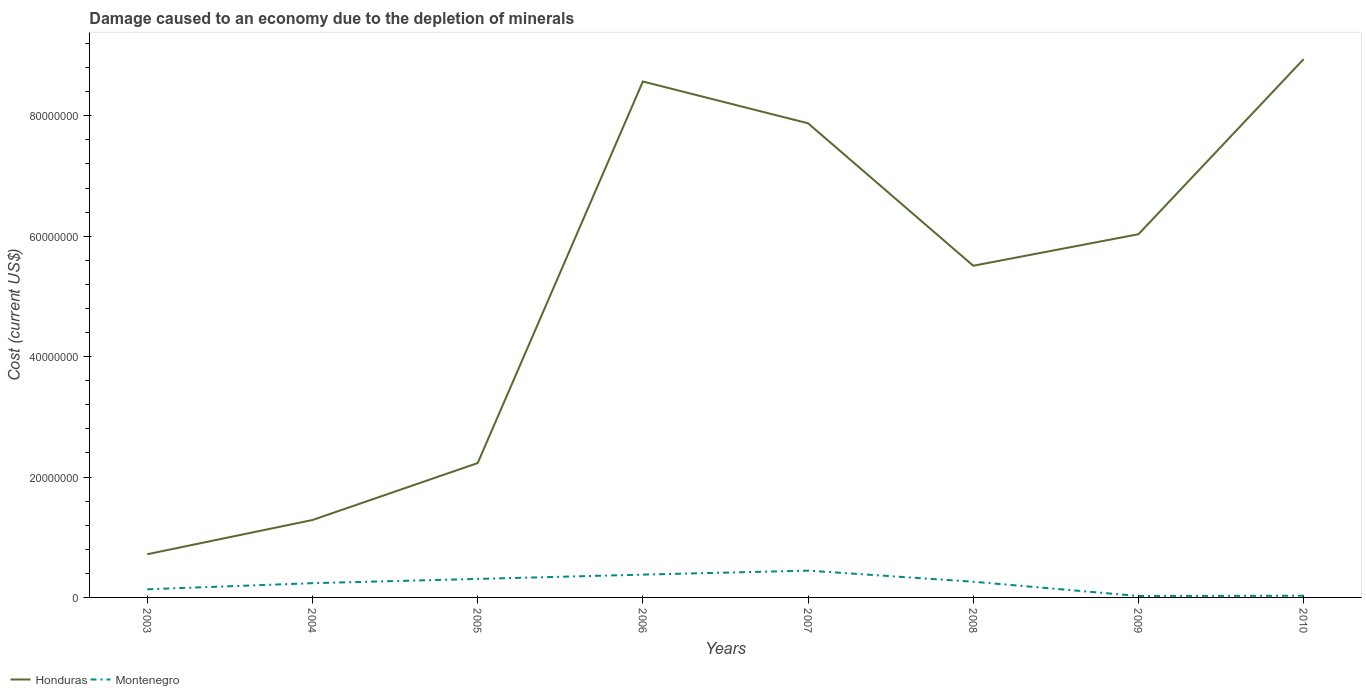Is the number of lines equal to the number of legend labels?
Offer a terse response. Yes. Across all years, what is the maximum cost of damage caused due to the depletion of minerals in Honduras?
Provide a short and direct response. 7.18e+06. What is the total cost of damage caused due to the depletion of minerals in Montenegro in the graph?
Your response must be concise. 3.51e+06. What is the difference between the highest and the second highest cost of damage caused due to the depletion of minerals in Montenegro?
Offer a very short reply. 4.21e+06. What is the difference between the highest and the lowest cost of damage caused due to the depletion of minerals in Montenegro?
Give a very brief answer. 5. How many lines are there?
Your answer should be very brief. 2. How many years are there in the graph?
Make the answer very short. 8. Does the graph contain any zero values?
Make the answer very short. No. Where does the legend appear in the graph?
Provide a succinct answer. Bottom left. How many legend labels are there?
Ensure brevity in your answer.  2. What is the title of the graph?
Give a very brief answer. Damage caused to an economy due to the depletion of minerals. What is the label or title of the Y-axis?
Provide a succinct answer. Cost (current US$). What is the Cost (current US$) of Honduras in 2003?
Offer a very short reply. 7.18e+06. What is the Cost (current US$) of Montenegro in 2003?
Keep it short and to the point. 1.35e+06. What is the Cost (current US$) of Honduras in 2004?
Your response must be concise. 1.29e+07. What is the Cost (current US$) in Montenegro in 2004?
Keep it short and to the point. 2.37e+06. What is the Cost (current US$) in Honduras in 2005?
Provide a succinct answer. 2.23e+07. What is the Cost (current US$) in Montenegro in 2005?
Your answer should be very brief. 3.07e+06. What is the Cost (current US$) in Honduras in 2006?
Provide a succinct answer. 8.57e+07. What is the Cost (current US$) of Montenegro in 2006?
Offer a very short reply. 3.79e+06. What is the Cost (current US$) in Honduras in 2007?
Your answer should be compact. 7.87e+07. What is the Cost (current US$) of Montenegro in 2007?
Your response must be concise. 4.45e+06. What is the Cost (current US$) of Honduras in 2008?
Make the answer very short. 5.51e+07. What is the Cost (current US$) in Montenegro in 2008?
Keep it short and to the point. 2.61e+06. What is the Cost (current US$) in Honduras in 2009?
Provide a short and direct response. 6.03e+07. What is the Cost (current US$) in Montenegro in 2009?
Provide a succinct answer. 2.40e+05. What is the Cost (current US$) of Honduras in 2010?
Your answer should be very brief. 8.94e+07. What is the Cost (current US$) of Montenegro in 2010?
Keep it short and to the point. 2.78e+05. Across all years, what is the maximum Cost (current US$) of Honduras?
Offer a terse response. 8.94e+07. Across all years, what is the maximum Cost (current US$) of Montenegro?
Your answer should be very brief. 4.45e+06. Across all years, what is the minimum Cost (current US$) of Honduras?
Provide a succinct answer. 7.18e+06. Across all years, what is the minimum Cost (current US$) of Montenegro?
Your answer should be compact. 2.40e+05. What is the total Cost (current US$) of Honduras in the graph?
Provide a succinct answer. 4.12e+08. What is the total Cost (current US$) in Montenegro in the graph?
Your answer should be very brief. 1.82e+07. What is the difference between the Cost (current US$) of Honduras in 2003 and that in 2004?
Make the answer very short. -5.68e+06. What is the difference between the Cost (current US$) in Montenegro in 2003 and that in 2004?
Offer a very short reply. -1.02e+06. What is the difference between the Cost (current US$) in Honduras in 2003 and that in 2005?
Offer a very short reply. -1.51e+07. What is the difference between the Cost (current US$) of Montenegro in 2003 and that in 2005?
Offer a very short reply. -1.72e+06. What is the difference between the Cost (current US$) in Honduras in 2003 and that in 2006?
Ensure brevity in your answer.  -7.85e+07. What is the difference between the Cost (current US$) of Montenegro in 2003 and that in 2006?
Offer a very short reply. -2.44e+06. What is the difference between the Cost (current US$) in Honduras in 2003 and that in 2007?
Your answer should be very brief. -7.16e+07. What is the difference between the Cost (current US$) of Montenegro in 2003 and that in 2007?
Your response must be concise. -3.10e+06. What is the difference between the Cost (current US$) in Honduras in 2003 and that in 2008?
Keep it short and to the point. -4.79e+07. What is the difference between the Cost (current US$) of Montenegro in 2003 and that in 2008?
Your answer should be compact. -1.26e+06. What is the difference between the Cost (current US$) in Honduras in 2003 and that in 2009?
Offer a terse response. -5.32e+07. What is the difference between the Cost (current US$) of Montenegro in 2003 and that in 2009?
Give a very brief answer. 1.11e+06. What is the difference between the Cost (current US$) in Honduras in 2003 and that in 2010?
Make the answer very short. -8.22e+07. What is the difference between the Cost (current US$) in Montenegro in 2003 and that in 2010?
Make the answer very short. 1.07e+06. What is the difference between the Cost (current US$) in Honduras in 2004 and that in 2005?
Your answer should be compact. -9.46e+06. What is the difference between the Cost (current US$) of Montenegro in 2004 and that in 2005?
Give a very brief answer. -7.07e+05. What is the difference between the Cost (current US$) of Honduras in 2004 and that in 2006?
Provide a succinct answer. -7.28e+07. What is the difference between the Cost (current US$) in Montenegro in 2004 and that in 2006?
Offer a very short reply. -1.42e+06. What is the difference between the Cost (current US$) of Honduras in 2004 and that in 2007?
Provide a short and direct response. -6.59e+07. What is the difference between the Cost (current US$) of Montenegro in 2004 and that in 2007?
Make the answer very short. -2.08e+06. What is the difference between the Cost (current US$) of Honduras in 2004 and that in 2008?
Your answer should be very brief. -4.22e+07. What is the difference between the Cost (current US$) in Montenegro in 2004 and that in 2008?
Ensure brevity in your answer.  -2.40e+05. What is the difference between the Cost (current US$) of Honduras in 2004 and that in 2009?
Offer a very short reply. -4.75e+07. What is the difference between the Cost (current US$) in Montenegro in 2004 and that in 2009?
Offer a very short reply. 2.13e+06. What is the difference between the Cost (current US$) in Honduras in 2004 and that in 2010?
Ensure brevity in your answer.  -7.66e+07. What is the difference between the Cost (current US$) of Montenegro in 2004 and that in 2010?
Your response must be concise. 2.09e+06. What is the difference between the Cost (current US$) of Honduras in 2005 and that in 2006?
Provide a short and direct response. -6.34e+07. What is the difference between the Cost (current US$) of Montenegro in 2005 and that in 2006?
Provide a short and direct response. -7.14e+05. What is the difference between the Cost (current US$) in Honduras in 2005 and that in 2007?
Ensure brevity in your answer.  -5.64e+07. What is the difference between the Cost (current US$) of Montenegro in 2005 and that in 2007?
Offer a very short reply. -1.38e+06. What is the difference between the Cost (current US$) of Honduras in 2005 and that in 2008?
Give a very brief answer. -3.28e+07. What is the difference between the Cost (current US$) of Montenegro in 2005 and that in 2008?
Your answer should be very brief. 4.67e+05. What is the difference between the Cost (current US$) in Honduras in 2005 and that in 2009?
Give a very brief answer. -3.80e+07. What is the difference between the Cost (current US$) of Montenegro in 2005 and that in 2009?
Provide a succinct answer. 2.83e+06. What is the difference between the Cost (current US$) of Honduras in 2005 and that in 2010?
Provide a short and direct response. -6.71e+07. What is the difference between the Cost (current US$) in Montenegro in 2005 and that in 2010?
Your answer should be compact. 2.80e+06. What is the difference between the Cost (current US$) in Honduras in 2006 and that in 2007?
Offer a very short reply. 6.94e+06. What is the difference between the Cost (current US$) in Montenegro in 2006 and that in 2007?
Your answer should be compact. -6.62e+05. What is the difference between the Cost (current US$) of Honduras in 2006 and that in 2008?
Offer a very short reply. 3.06e+07. What is the difference between the Cost (current US$) in Montenegro in 2006 and that in 2008?
Provide a short and direct response. 1.18e+06. What is the difference between the Cost (current US$) of Honduras in 2006 and that in 2009?
Provide a succinct answer. 2.54e+07. What is the difference between the Cost (current US$) of Montenegro in 2006 and that in 2009?
Make the answer very short. 3.55e+06. What is the difference between the Cost (current US$) in Honduras in 2006 and that in 2010?
Your response must be concise. -3.72e+06. What is the difference between the Cost (current US$) in Montenegro in 2006 and that in 2010?
Your answer should be compact. 3.51e+06. What is the difference between the Cost (current US$) in Honduras in 2007 and that in 2008?
Your answer should be very brief. 2.37e+07. What is the difference between the Cost (current US$) of Montenegro in 2007 and that in 2008?
Your answer should be compact. 1.84e+06. What is the difference between the Cost (current US$) in Honduras in 2007 and that in 2009?
Provide a short and direct response. 1.84e+07. What is the difference between the Cost (current US$) in Montenegro in 2007 and that in 2009?
Make the answer very short. 4.21e+06. What is the difference between the Cost (current US$) in Honduras in 2007 and that in 2010?
Your answer should be very brief. -1.07e+07. What is the difference between the Cost (current US$) of Montenegro in 2007 and that in 2010?
Your answer should be compact. 4.17e+06. What is the difference between the Cost (current US$) in Honduras in 2008 and that in 2009?
Ensure brevity in your answer.  -5.24e+06. What is the difference between the Cost (current US$) in Montenegro in 2008 and that in 2009?
Provide a short and direct response. 2.37e+06. What is the difference between the Cost (current US$) in Honduras in 2008 and that in 2010?
Make the answer very short. -3.43e+07. What is the difference between the Cost (current US$) in Montenegro in 2008 and that in 2010?
Ensure brevity in your answer.  2.33e+06. What is the difference between the Cost (current US$) of Honduras in 2009 and that in 2010?
Your response must be concise. -2.91e+07. What is the difference between the Cost (current US$) in Montenegro in 2009 and that in 2010?
Make the answer very short. -3.74e+04. What is the difference between the Cost (current US$) of Honduras in 2003 and the Cost (current US$) of Montenegro in 2004?
Your response must be concise. 4.81e+06. What is the difference between the Cost (current US$) of Honduras in 2003 and the Cost (current US$) of Montenegro in 2005?
Your answer should be compact. 4.10e+06. What is the difference between the Cost (current US$) of Honduras in 2003 and the Cost (current US$) of Montenegro in 2006?
Ensure brevity in your answer.  3.39e+06. What is the difference between the Cost (current US$) in Honduras in 2003 and the Cost (current US$) in Montenegro in 2007?
Give a very brief answer. 2.73e+06. What is the difference between the Cost (current US$) of Honduras in 2003 and the Cost (current US$) of Montenegro in 2008?
Your answer should be compact. 4.57e+06. What is the difference between the Cost (current US$) in Honduras in 2003 and the Cost (current US$) in Montenegro in 2009?
Ensure brevity in your answer.  6.94e+06. What is the difference between the Cost (current US$) of Honduras in 2003 and the Cost (current US$) of Montenegro in 2010?
Ensure brevity in your answer.  6.90e+06. What is the difference between the Cost (current US$) of Honduras in 2004 and the Cost (current US$) of Montenegro in 2005?
Offer a terse response. 9.79e+06. What is the difference between the Cost (current US$) in Honduras in 2004 and the Cost (current US$) in Montenegro in 2006?
Ensure brevity in your answer.  9.07e+06. What is the difference between the Cost (current US$) of Honduras in 2004 and the Cost (current US$) of Montenegro in 2007?
Make the answer very short. 8.41e+06. What is the difference between the Cost (current US$) in Honduras in 2004 and the Cost (current US$) in Montenegro in 2008?
Offer a very short reply. 1.03e+07. What is the difference between the Cost (current US$) of Honduras in 2004 and the Cost (current US$) of Montenegro in 2009?
Your answer should be very brief. 1.26e+07. What is the difference between the Cost (current US$) of Honduras in 2004 and the Cost (current US$) of Montenegro in 2010?
Offer a terse response. 1.26e+07. What is the difference between the Cost (current US$) of Honduras in 2005 and the Cost (current US$) of Montenegro in 2006?
Make the answer very short. 1.85e+07. What is the difference between the Cost (current US$) in Honduras in 2005 and the Cost (current US$) in Montenegro in 2007?
Your answer should be compact. 1.79e+07. What is the difference between the Cost (current US$) in Honduras in 2005 and the Cost (current US$) in Montenegro in 2008?
Your answer should be compact. 1.97e+07. What is the difference between the Cost (current US$) of Honduras in 2005 and the Cost (current US$) of Montenegro in 2009?
Provide a succinct answer. 2.21e+07. What is the difference between the Cost (current US$) of Honduras in 2005 and the Cost (current US$) of Montenegro in 2010?
Make the answer very short. 2.20e+07. What is the difference between the Cost (current US$) of Honduras in 2006 and the Cost (current US$) of Montenegro in 2007?
Your response must be concise. 8.12e+07. What is the difference between the Cost (current US$) in Honduras in 2006 and the Cost (current US$) in Montenegro in 2008?
Your response must be concise. 8.31e+07. What is the difference between the Cost (current US$) of Honduras in 2006 and the Cost (current US$) of Montenegro in 2009?
Provide a short and direct response. 8.54e+07. What is the difference between the Cost (current US$) of Honduras in 2006 and the Cost (current US$) of Montenegro in 2010?
Ensure brevity in your answer.  8.54e+07. What is the difference between the Cost (current US$) of Honduras in 2007 and the Cost (current US$) of Montenegro in 2008?
Provide a short and direct response. 7.61e+07. What is the difference between the Cost (current US$) of Honduras in 2007 and the Cost (current US$) of Montenegro in 2009?
Your answer should be compact. 7.85e+07. What is the difference between the Cost (current US$) in Honduras in 2007 and the Cost (current US$) in Montenegro in 2010?
Keep it short and to the point. 7.85e+07. What is the difference between the Cost (current US$) of Honduras in 2008 and the Cost (current US$) of Montenegro in 2009?
Provide a succinct answer. 5.48e+07. What is the difference between the Cost (current US$) of Honduras in 2008 and the Cost (current US$) of Montenegro in 2010?
Keep it short and to the point. 5.48e+07. What is the difference between the Cost (current US$) in Honduras in 2009 and the Cost (current US$) in Montenegro in 2010?
Your answer should be very brief. 6.00e+07. What is the average Cost (current US$) in Honduras per year?
Your answer should be very brief. 5.15e+07. What is the average Cost (current US$) of Montenegro per year?
Provide a short and direct response. 2.27e+06. In the year 2003, what is the difference between the Cost (current US$) of Honduras and Cost (current US$) of Montenegro?
Provide a succinct answer. 5.83e+06. In the year 2004, what is the difference between the Cost (current US$) of Honduras and Cost (current US$) of Montenegro?
Your answer should be compact. 1.05e+07. In the year 2005, what is the difference between the Cost (current US$) in Honduras and Cost (current US$) in Montenegro?
Give a very brief answer. 1.92e+07. In the year 2006, what is the difference between the Cost (current US$) of Honduras and Cost (current US$) of Montenegro?
Offer a terse response. 8.19e+07. In the year 2007, what is the difference between the Cost (current US$) in Honduras and Cost (current US$) in Montenegro?
Your answer should be very brief. 7.43e+07. In the year 2008, what is the difference between the Cost (current US$) of Honduras and Cost (current US$) of Montenegro?
Provide a succinct answer. 5.25e+07. In the year 2009, what is the difference between the Cost (current US$) of Honduras and Cost (current US$) of Montenegro?
Give a very brief answer. 6.01e+07. In the year 2010, what is the difference between the Cost (current US$) of Honduras and Cost (current US$) of Montenegro?
Ensure brevity in your answer.  8.91e+07. What is the ratio of the Cost (current US$) of Honduras in 2003 to that in 2004?
Keep it short and to the point. 0.56. What is the ratio of the Cost (current US$) in Montenegro in 2003 to that in 2004?
Offer a terse response. 0.57. What is the ratio of the Cost (current US$) of Honduras in 2003 to that in 2005?
Provide a succinct answer. 0.32. What is the ratio of the Cost (current US$) in Montenegro in 2003 to that in 2005?
Provide a short and direct response. 0.44. What is the ratio of the Cost (current US$) of Honduras in 2003 to that in 2006?
Provide a short and direct response. 0.08. What is the ratio of the Cost (current US$) of Montenegro in 2003 to that in 2006?
Ensure brevity in your answer.  0.36. What is the ratio of the Cost (current US$) in Honduras in 2003 to that in 2007?
Your answer should be compact. 0.09. What is the ratio of the Cost (current US$) in Montenegro in 2003 to that in 2007?
Make the answer very short. 0.3. What is the ratio of the Cost (current US$) of Honduras in 2003 to that in 2008?
Offer a very short reply. 0.13. What is the ratio of the Cost (current US$) in Montenegro in 2003 to that in 2008?
Your response must be concise. 0.52. What is the ratio of the Cost (current US$) of Honduras in 2003 to that in 2009?
Offer a terse response. 0.12. What is the ratio of the Cost (current US$) of Montenegro in 2003 to that in 2009?
Provide a succinct answer. 5.61. What is the ratio of the Cost (current US$) in Honduras in 2003 to that in 2010?
Offer a very short reply. 0.08. What is the ratio of the Cost (current US$) in Montenegro in 2003 to that in 2010?
Give a very brief answer. 4.86. What is the ratio of the Cost (current US$) in Honduras in 2004 to that in 2005?
Your response must be concise. 0.58. What is the ratio of the Cost (current US$) of Montenegro in 2004 to that in 2005?
Provide a short and direct response. 0.77. What is the ratio of the Cost (current US$) of Honduras in 2004 to that in 2006?
Your answer should be compact. 0.15. What is the ratio of the Cost (current US$) of Montenegro in 2004 to that in 2006?
Make the answer very short. 0.62. What is the ratio of the Cost (current US$) of Honduras in 2004 to that in 2007?
Give a very brief answer. 0.16. What is the ratio of the Cost (current US$) of Montenegro in 2004 to that in 2007?
Your response must be concise. 0.53. What is the ratio of the Cost (current US$) of Honduras in 2004 to that in 2008?
Offer a very short reply. 0.23. What is the ratio of the Cost (current US$) of Montenegro in 2004 to that in 2008?
Ensure brevity in your answer.  0.91. What is the ratio of the Cost (current US$) of Honduras in 2004 to that in 2009?
Your answer should be compact. 0.21. What is the ratio of the Cost (current US$) of Montenegro in 2004 to that in 2009?
Provide a succinct answer. 9.84. What is the ratio of the Cost (current US$) in Honduras in 2004 to that in 2010?
Your answer should be very brief. 0.14. What is the ratio of the Cost (current US$) of Montenegro in 2004 to that in 2010?
Provide a succinct answer. 8.52. What is the ratio of the Cost (current US$) in Honduras in 2005 to that in 2006?
Offer a terse response. 0.26. What is the ratio of the Cost (current US$) of Montenegro in 2005 to that in 2006?
Your response must be concise. 0.81. What is the ratio of the Cost (current US$) of Honduras in 2005 to that in 2007?
Provide a short and direct response. 0.28. What is the ratio of the Cost (current US$) in Montenegro in 2005 to that in 2007?
Offer a terse response. 0.69. What is the ratio of the Cost (current US$) in Honduras in 2005 to that in 2008?
Offer a terse response. 0.41. What is the ratio of the Cost (current US$) in Montenegro in 2005 to that in 2008?
Provide a succinct answer. 1.18. What is the ratio of the Cost (current US$) in Honduras in 2005 to that in 2009?
Your answer should be compact. 0.37. What is the ratio of the Cost (current US$) of Montenegro in 2005 to that in 2009?
Your answer should be compact. 12.78. What is the ratio of the Cost (current US$) in Honduras in 2005 to that in 2010?
Your answer should be very brief. 0.25. What is the ratio of the Cost (current US$) of Montenegro in 2005 to that in 2010?
Provide a succinct answer. 11.06. What is the ratio of the Cost (current US$) of Honduras in 2006 to that in 2007?
Your answer should be compact. 1.09. What is the ratio of the Cost (current US$) of Montenegro in 2006 to that in 2007?
Offer a very short reply. 0.85. What is the ratio of the Cost (current US$) in Honduras in 2006 to that in 2008?
Provide a succinct answer. 1.56. What is the ratio of the Cost (current US$) of Montenegro in 2006 to that in 2008?
Your answer should be compact. 1.45. What is the ratio of the Cost (current US$) in Honduras in 2006 to that in 2009?
Your response must be concise. 1.42. What is the ratio of the Cost (current US$) of Montenegro in 2006 to that in 2009?
Offer a very short reply. 15.75. What is the ratio of the Cost (current US$) in Honduras in 2006 to that in 2010?
Make the answer very short. 0.96. What is the ratio of the Cost (current US$) of Montenegro in 2006 to that in 2010?
Your answer should be very brief. 13.63. What is the ratio of the Cost (current US$) of Honduras in 2007 to that in 2008?
Ensure brevity in your answer.  1.43. What is the ratio of the Cost (current US$) of Montenegro in 2007 to that in 2008?
Give a very brief answer. 1.71. What is the ratio of the Cost (current US$) in Honduras in 2007 to that in 2009?
Make the answer very short. 1.31. What is the ratio of the Cost (current US$) in Montenegro in 2007 to that in 2009?
Make the answer very short. 18.5. What is the ratio of the Cost (current US$) of Honduras in 2007 to that in 2010?
Your answer should be very brief. 0.88. What is the ratio of the Cost (current US$) of Montenegro in 2007 to that in 2010?
Give a very brief answer. 16.01. What is the ratio of the Cost (current US$) of Honduras in 2008 to that in 2009?
Give a very brief answer. 0.91. What is the ratio of the Cost (current US$) in Montenegro in 2008 to that in 2009?
Keep it short and to the point. 10.84. What is the ratio of the Cost (current US$) of Honduras in 2008 to that in 2010?
Keep it short and to the point. 0.62. What is the ratio of the Cost (current US$) of Montenegro in 2008 to that in 2010?
Keep it short and to the point. 9.38. What is the ratio of the Cost (current US$) in Honduras in 2009 to that in 2010?
Make the answer very short. 0.67. What is the ratio of the Cost (current US$) in Montenegro in 2009 to that in 2010?
Provide a short and direct response. 0.87. What is the difference between the highest and the second highest Cost (current US$) in Honduras?
Give a very brief answer. 3.72e+06. What is the difference between the highest and the second highest Cost (current US$) in Montenegro?
Ensure brevity in your answer.  6.62e+05. What is the difference between the highest and the lowest Cost (current US$) of Honduras?
Offer a terse response. 8.22e+07. What is the difference between the highest and the lowest Cost (current US$) of Montenegro?
Your response must be concise. 4.21e+06. 